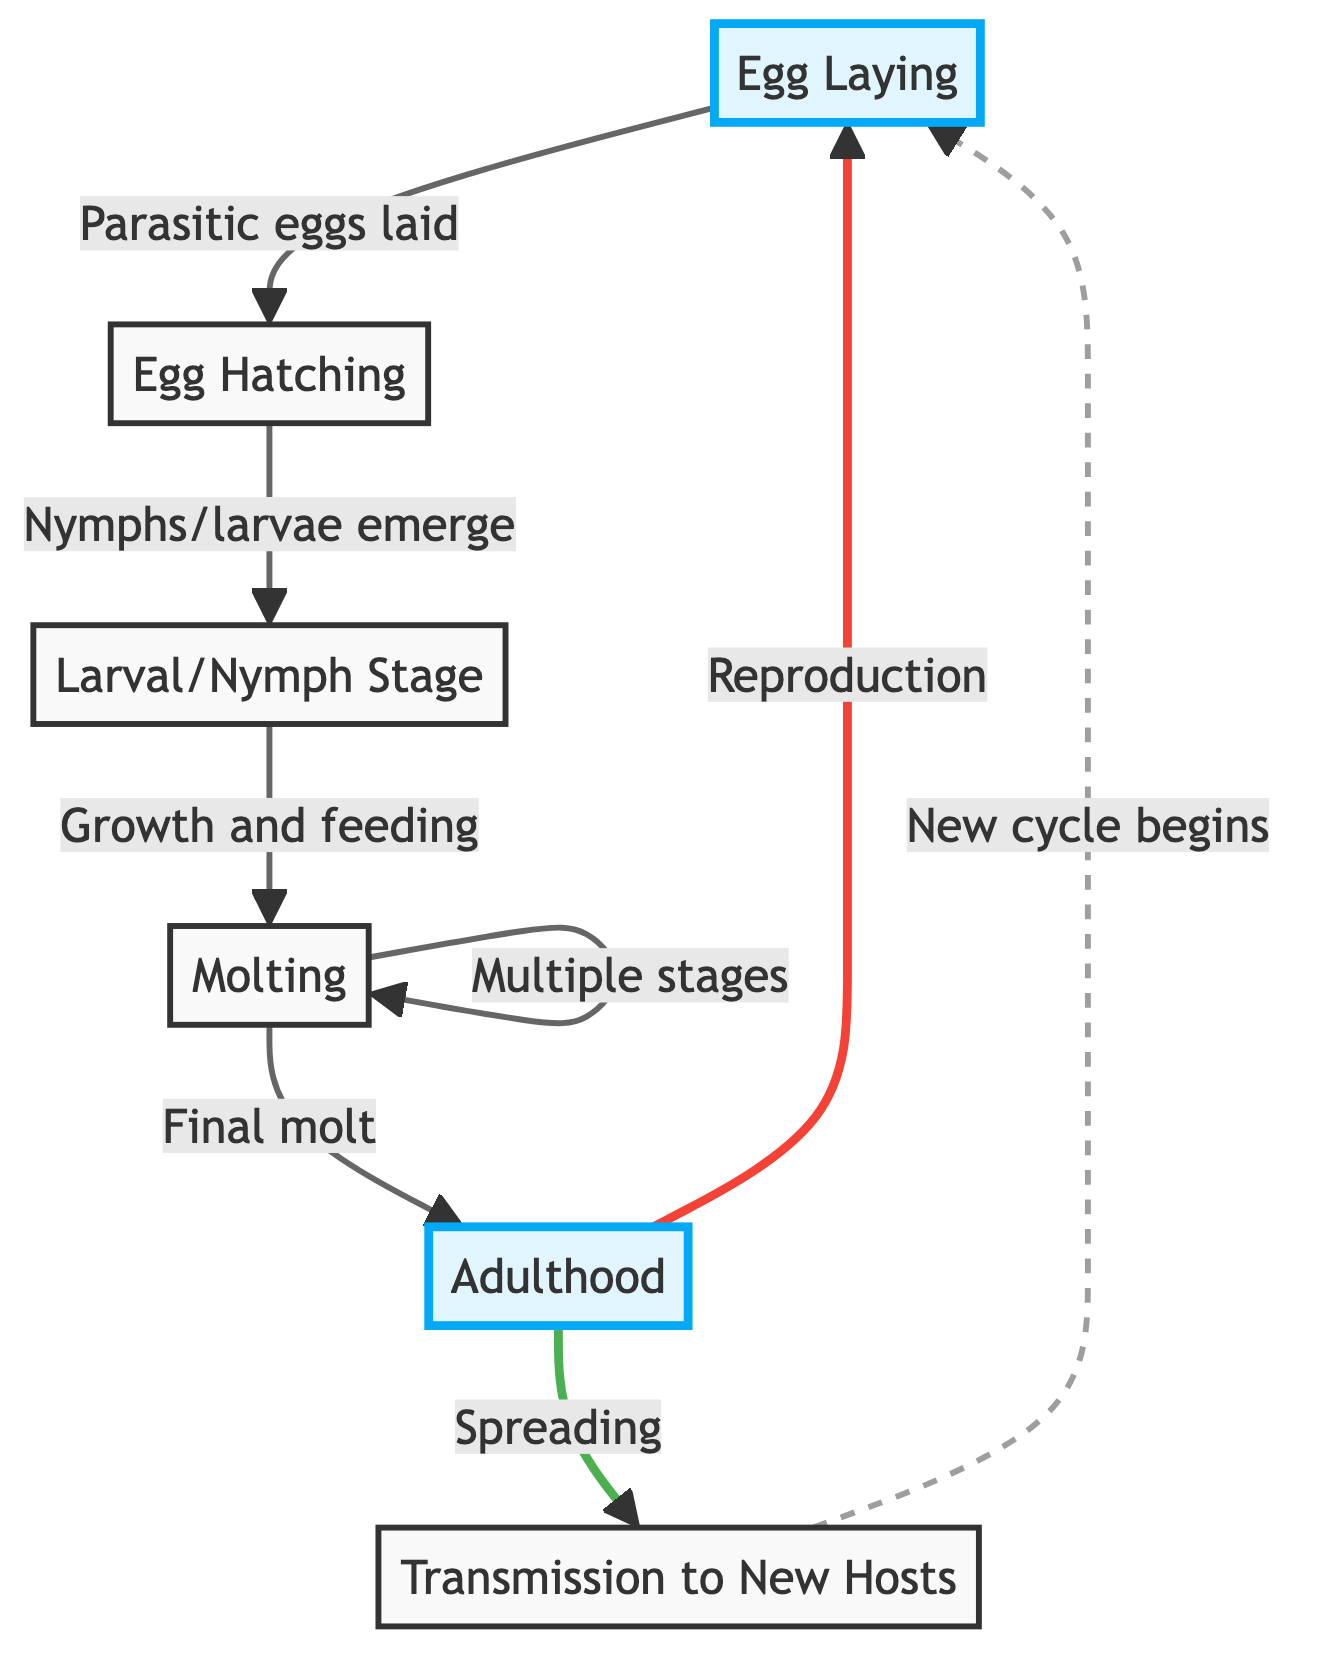What is the first step in the lifecycle of avian parasites? The first step in the lifecycle is "Egg Laying," where parasitic eggs are laid by female parasites on bird feathers or skin.
Answer: Egg Laying How many main stages are identified in the lifecycle? The diagram identifies five main stages in the lifecycle: Egg Laying, Egg Hatching, Larval/Nymph Stage, Molting, and Adulthood.
Answer: Five What happens after "Egg Hatching"? After "Egg Hatching," nymphs or larvae emerge, entering the "Larval/Nymph Stage," where they begin feeding on the host bird.
Answer: Larval/Nymph Stage What is the final stage of the lifecycle before returning to egg laying? The final stage before returning to egg laying is "Adulthood," where adult parasites continue feeding and reproduce to lay eggs.
Answer: Adulthood What indicates a new cycle begins in the lifecycle? A new cycle begins when parasites spread to new host birds through "Transmission to New Hosts," which leads back to "Egg Laying."
Answer: Transmission to New Hosts What does the molting process involve? The molting process involves parasitic nymphs undergoing several stages to reach adulthood, with each stage requiring shedding of their exoskeleton.
Answer: Shedding exoskeleton How are parasites transmitted to new hosts? Parasites are transmitted to new hosts through direct contact, shared nesting materials, or close proximity in roosting areas as indicated in "Transmission to New Hosts."
Answer: Direct contact, shared nesting materials, or proximity What do adult parasites do aside from feeding on host birds? Besides feeding on host birds, adult parasites are capable of reproduction, allowing them to lay eggs and continue the lifecycle.
Answer: Reproduction How many molting stages do nymphs undergo before reaching adulthood? Nymphs undergo multiple molting stages before they finally molt into adulthood. However, the exact number of stages is not specified.
Answer: Multiple stages 